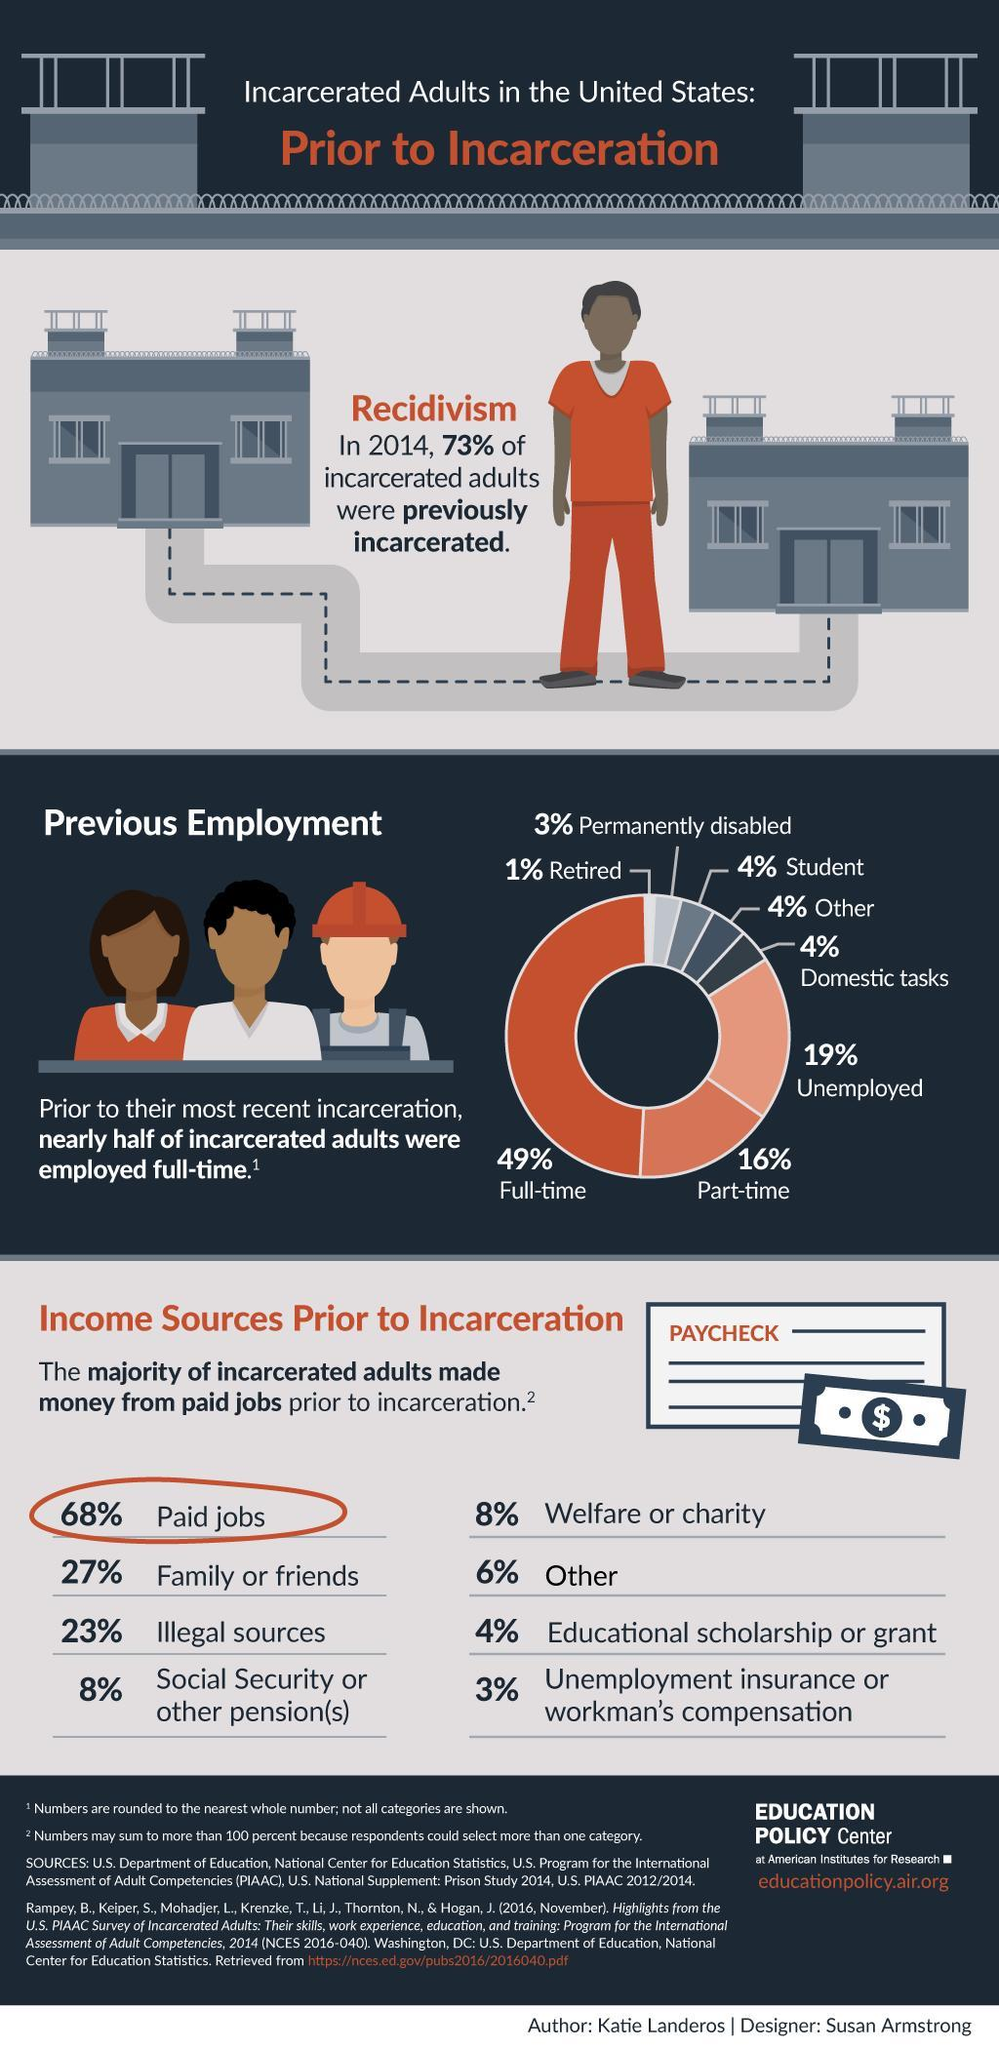What is the total percentage of income from grants and others prior to incarceration?
Answer the question with a short phrase. 10% What is the total percentage of income from illegal sources and charity prior to incarceration? 31% Which is second lowest income source prior to incarceration ? Educational Scholarship or Grant What is percentage of incarcerated adults are  constituted by students, others and domestic tasks? 12% What is the second lowest percentage of incarcerated adults in the chart? 3% What is the second highest percentage of incarcerated adults in the chart? 16% What  percentage of incarcerated adults are constituted by unemployed and retired? 20% Which is the third highest income group source prior to incarceration ? Illegal sources 